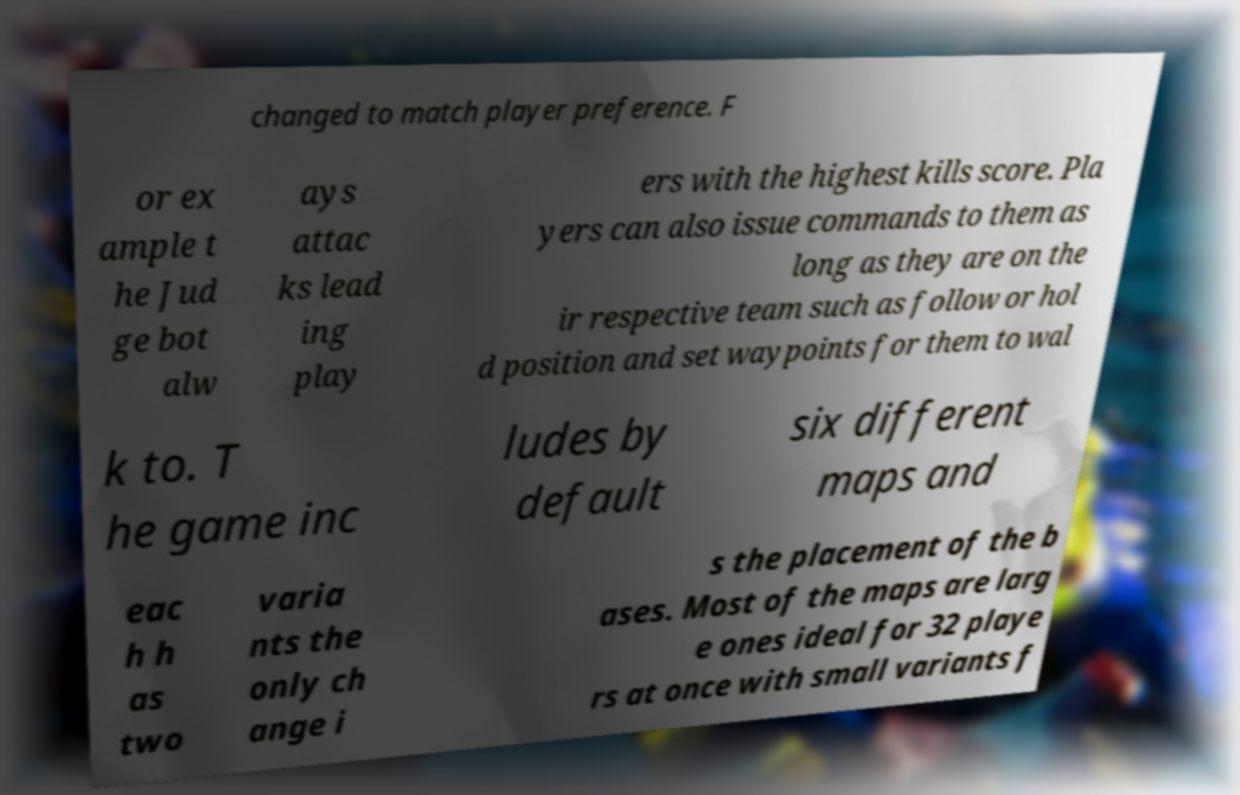Please identify and transcribe the text found in this image. changed to match player preference. F or ex ample t he Jud ge bot alw ays attac ks lead ing play ers with the highest kills score. Pla yers can also issue commands to them as long as they are on the ir respective team such as follow or hol d position and set waypoints for them to wal k to. T he game inc ludes by default six different maps and eac h h as two varia nts the only ch ange i s the placement of the b ases. Most of the maps are larg e ones ideal for 32 playe rs at once with small variants f 